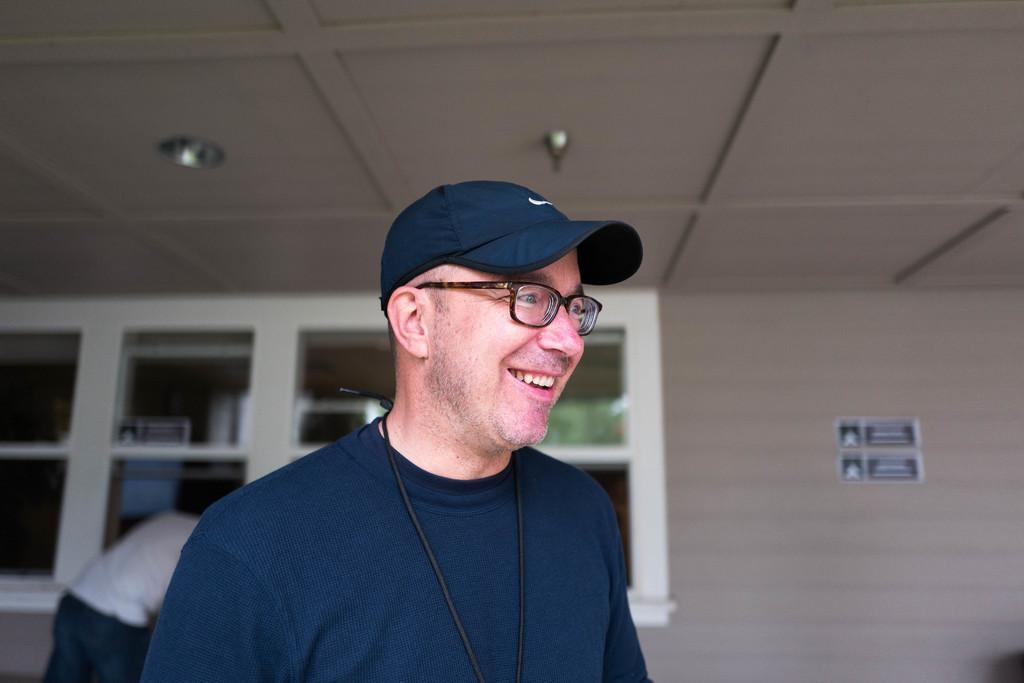In one or two sentences, can you explain what this image depicts? In this image I can see a person standing and smiling and in the background there is a wall ,window and a person. And at the top of the image there is a ceiling. 